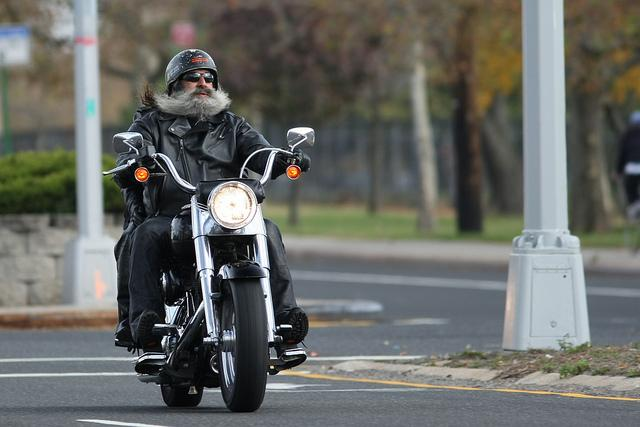What does the brown hair belong to? man 